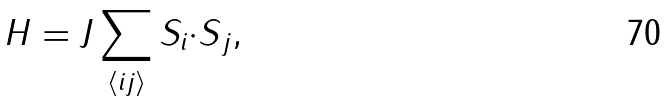Convert formula to latex. <formula><loc_0><loc_0><loc_500><loc_500>H = J \sum _ { \langle i j \rangle } { S } _ { i } { \cdot S } _ { j } ,</formula> 